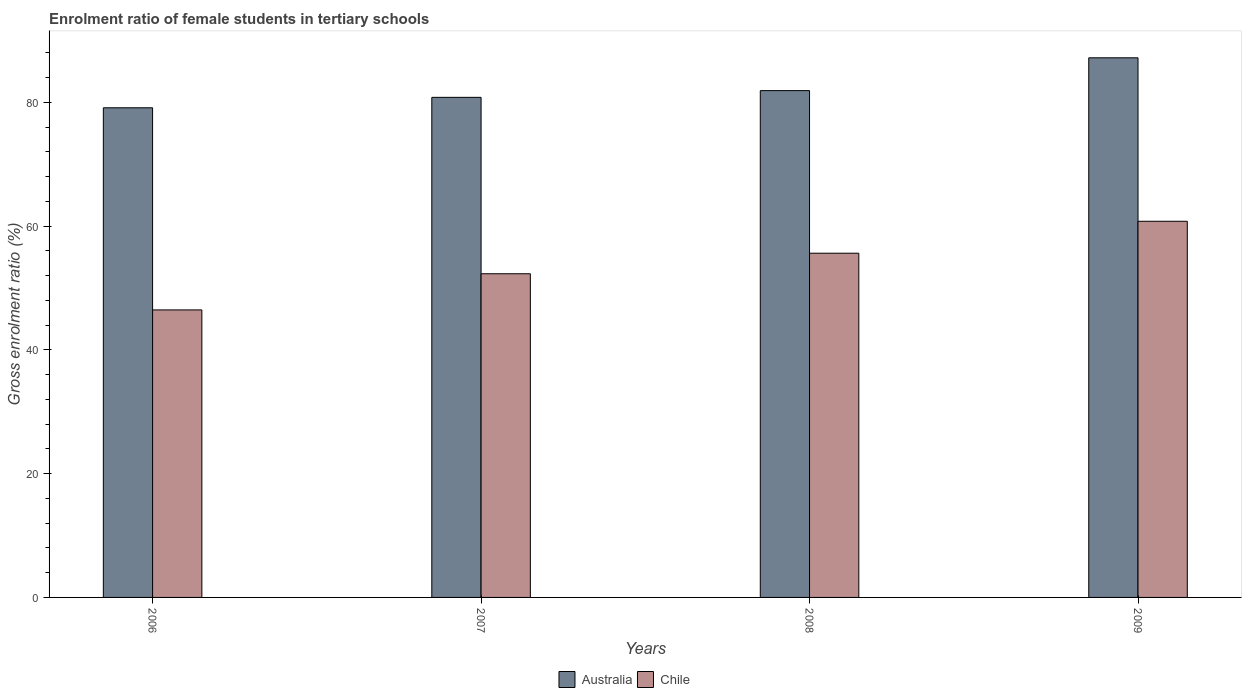Are the number of bars per tick equal to the number of legend labels?
Offer a terse response. Yes. How many bars are there on the 3rd tick from the left?
Provide a succinct answer. 2. In how many cases, is the number of bars for a given year not equal to the number of legend labels?
Make the answer very short. 0. What is the enrolment ratio of female students in tertiary schools in Australia in 2007?
Keep it short and to the point. 80.82. Across all years, what is the maximum enrolment ratio of female students in tertiary schools in Chile?
Provide a succinct answer. 60.79. Across all years, what is the minimum enrolment ratio of female students in tertiary schools in Chile?
Give a very brief answer. 46.46. In which year was the enrolment ratio of female students in tertiary schools in Chile minimum?
Provide a succinct answer. 2006. What is the total enrolment ratio of female students in tertiary schools in Australia in the graph?
Provide a short and direct response. 329.05. What is the difference between the enrolment ratio of female students in tertiary schools in Chile in 2007 and that in 2009?
Your answer should be very brief. -8.48. What is the difference between the enrolment ratio of female students in tertiary schools in Chile in 2008 and the enrolment ratio of female students in tertiary schools in Australia in 2006?
Offer a very short reply. -23.5. What is the average enrolment ratio of female students in tertiary schools in Chile per year?
Keep it short and to the point. 53.8. In the year 2006, what is the difference between the enrolment ratio of female students in tertiary schools in Australia and enrolment ratio of female students in tertiary schools in Chile?
Offer a very short reply. 32.67. What is the ratio of the enrolment ratio of female students in tertiary schools in Chile in 2006 to that in 2009?
Your answer should be compact. 0.76. Is the enrolment ratio of female students in tertiary schools in Australia in 2006 less than that in 2009?
Your answer should be very brief. Yes. Is the difference between the enrolment ratio of female students in tertiary schools in Australia in 2007 and 2008 greater than the difference between the enrolment ratio of female students in tertiary schools in Chile in 2007 and 2008?
Your answer should be very brief. Yes. What is the difference between the highest and the second highest enrolment ratio of female students in tertiary schools in Chile?
Make the answer very short. 5.16. What is the difference between the highest and the lowest enrolment ratio of female students in tertiary schools in Chile?
Keep it short and to the point. 14.33. Is the sum of the enrolment ratio of female students in tertiary schools in Chile in 2007 and 2009 greater than the maximum enrolment ratio of female students in tertiary schools in Australia across all years?
Provide a short and direct response. Yes. What does the 1st bar from the left in 2009 represents?
Provide a short and direct response. Australia. What does the 1st bar from the right in 2007 represents?
Provide a succinct answer. Chile. How many bars are there?
Keep it short and to the point. 8. Does the graph contain any zero values?
Keep it short and to the point. No. What is the title of the graph?
Give a very brief answer. Enrolment ratio of female students in tertiary schools. What is the label or title of the Y-axis?
Provide a short and direct response. Gross enrolment ratio (%). What is the Gross enrolment ratio (%) in Australia in 2006?
Provide a short and direct response. 79.13. What is the Gross enrolment ratio (%) in Chile in 2006?
Your answer should be compact. 46.46. What is the Gross enrolment ratio (%) of Australia in 2007?
Ensure brevity in your answer.  80.82. What is the Gross enrolment ratio (%) of Chile in 2007?
Your answer should be compact. 52.31. What is the Gross enrolment ratio (%) in Australia in 2008?
Your answer should be very brief. 81.9. What is the Gross enrolment ratio (%) in Chile in 2008?
Your answer should be compact. 55.63. What is the Gross enrolment ratio (%) in Australia in 2009?
Offer a terse response. 87.21. What is the Gross enrolment ratio (%) in Chile in 2009?
Offer a terse response. 60.79. Across all years, what is the maximum Gross enrolment ratio (%) in Australia?
Offer a very short reply. 87.21. Across all years, what is the maximum Gross enrolment ratio (%) in Chile?
Provide a succinct answer. 60.79. Across all years, what is the minimum Gross enrolment ratio (%) of Australia?
Offer a very short reply. 79.13. Across all years, what is the minimum Gross enrolment ratio (%) of Chile?
Make the answer very short. 46.46. What is the total Gross enrolment ratio (%) of Australia in the graph?
Your response must be concise. 329.05. What is the total Gross enrolment ratio (%) of Chile in the graph?
Your response must be concise. 215.18. What is the difference between the Gross enrolment ratio (%) of Australia in 2006 and that in 2007?
Offer a terse response. -1.69. What is the difference between the Gross enrolment ratio (%) in Chile in 2006 and that in 2007?
Provide a succinct answer. -5.84. What is the difference between the Gross enrolment ratio (%) of Australia in 2006 and that in 2008?
Ensure brevity in your answer.  -2.78. What is the difference between the Gross enrolment ratio (%) in Chile in 2006 and that in 2008?
Your response must be concise. -9.17. What is the difference between the Gross enrolment ratio (%) in Australia in 2006 and that in 2009?
Provide a short and direct response. -8.08. What is the difference between the Gross enrolment ratio (%) in Chile in 2006 and that in 2009?
Make the answer very short. -14.33. What is the difference between the Gross enrolment ratio (%) in Australia in 2007 and that in 2008?
Provide a succinct answer. -1.09. What is the difference between the Gross enrolment ratio (%) in Chile in 2007 and that in 2008?
Your answer should be very brief. -3.32. What is the difference between the Gross enrolment ratio (%) in Australia in 2007 and that in 2009?
Make the answer very short. -6.39. What is the difference between the Gross enrolment ratio (%) in Chile in 2007 and that in 2009?
Make the answer very short. -8.48. What is the difference between the Gross enrolment ratio (%) in Australia in 2008 and that in 2009?
Offer a very short reply. -5.3. What is the difference between the Gross enrolment ratio (%) of Chile in 2008 and that in 2009?
Your answer should be very brief. -5.16. What is the difference between the Gross enrolment ratio (%) in Australia in 2006 and the Gross enrolment ratio (%) in Chile in 2007?
Keep it short and to the point. 26.82. What is the difference between the Gross enrolment ratio (%) in Australia in 2006 and the Gross enrolment ratio (%) in Chile in 2008?
Give a very brief answer. 23.5. What is the difference between the Gross enrolment ratio (%) in Australia in 2006 and the Gross enrolment ratio (%) in Chile in 2009?
Give a very brief answer. 18.34. What is the difference between the Gross enrolment ratio (%) in Australia in 2007 and the Gross enrolment ratio (%) in Chile in 2008?
Provide a short and direct response. 25.19. What is the difference between the Gross enrolment ratio (%) in Australia in 2007 and the Gross enrolment ratio (%) in Chile in 2009?
Your response must be concise. 20.03. What is the difference between the Gross enrolment ratio (%) in Australia in 2008 and the Gross enrolment ratio (%) in Chile in 2009?
Make the answer very short. 21.12. What is the average Gross enrolment ratio (%) in Australia per year?
Give a very brief answer. 82.26. What is the average Gross enrolment ratio (%) in Chile per year?
Provide a short and direct response. 53.8. In the year 2006, what is the difference between the Gross enrolment ratio (%) in Australia and Gross enrolment ratio (%) in Chile?
Make the answer very short. 32.67. In the year 2007, what is the difference between the Gross enrolment ratio (%) in Australia and Gross enrolment ratio (%) in Chile?
Ensure brevity in your answer.  28.51. In the year 2008, what is the difference between the Gross enrolment ratio (%) in Australia and Gross enrolment ratio (%) in Chile?
Your answer should be very brief. 26.28. In the year 2009, what is the difference between the Gross enrolment ratio (%) of Australia and Gross enrolment ratio (%) of Chile?
Provide a succinct answer. 26.42. What is the ratio of the Gross enrolment ratio (%) of Australia in 2006 to that in 2007?
Provide a succinct answer. 0.98. What is the ratio of the Gross enrolment ratio (%) in Chile in 2006 to that in 2007?
Ensure brevity in your answer.  0.89. What is the ratio of the Gross enrolment ratio (%) in Australia in 2006 to that in 2008?
Keep it short and to the point. 0.97. What is the ratio of the Gross enrolment ratio (%) of Chile in 2006 to that in 2008?
Provide a short and direct response. 0.84. What is the ratio of the Gross enrolment ratio (%) of Australia in 2006 to that in 2009?
Ensure brevity in your answer.  0.91. What is the ratio of the Gross enrolment ratio (%) of Chile in 2006 to that in 2009?
Your answer should be compact. 0.76. What is the ratio of the Gross enrolment ratio (%) of Australia in 2007 to that in 2008?
Give a very brief answer. 0.99. What is the ratio of the Gross enrolment ratio (%) of Chile in 2007 to that in 2008?
Make the answer very short. 0.94. What is the ratio of the Gross enrolment ratio (%) of Australia in 2007 to that in 2009?
Offer a very short reply. 0.93. What is the ratio of the Gross enrolment ratio (%) of Chile in 2007 to that in 2009?
Provide a succinct answer. 0.86. What is the ratio of the Gross enrolment ratio (%) of Australia in 2008 to that in 2009?
Give a very brief answer. 0.94. What is the ratio of the Gross enrolment ratio (%) in Chile in 2008 to that in 2009?
Provide a short and direct response. 0.92. What is the difference between the highest and the second highest Gross enrolment ratio (%) of Australia?
Make the answer very short. 5.3. What is the difference between the highest and the second highest Gross enrolment ratio (%) in Chile?
Keep it short and to the point. 5.16. What is the difference between the highest and the lowest Gross enrolment ratio (%) of Australia?
Give a very brief answer. 8.08. What is the difference between the highest and the lowest Gross enrolment ratio (%) of Chile?
Your answer should be compact. 14.33. 